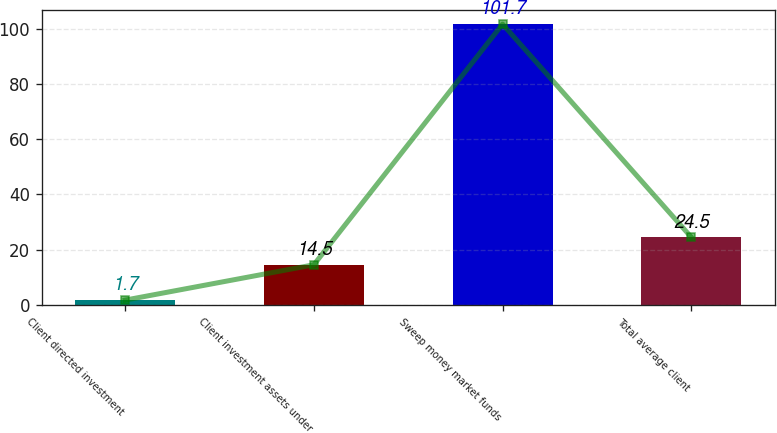Convert chart to OTSL. <chart><loc_0><loc_0><loc_500><loc_500><bar_chart><fcel>Client directed investment<fcel>Client investment assets under<fcel>Sweep money market funds<fcel>Total average client<nl><fcel>1.7<fcel>14.5<fcel>101.7<fcel>24.5<nl></chart> 